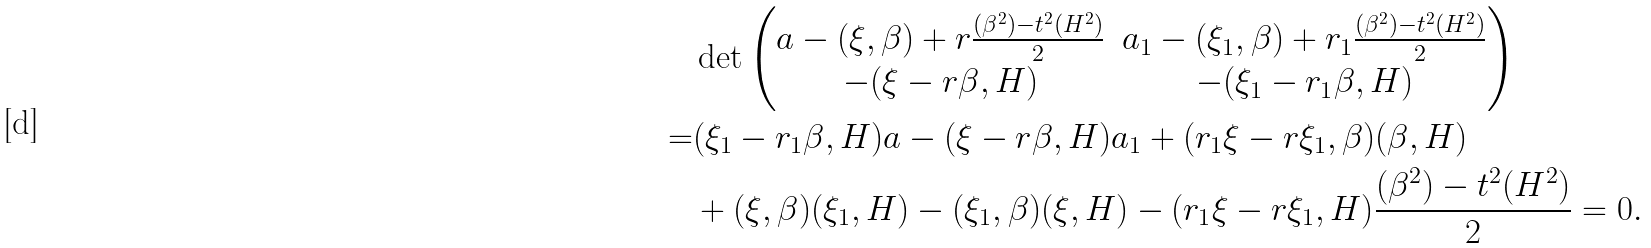<formula> <loc_0><loc_0><loc_500><loc_500>& \det \begin{pmatrix} a - ( \xi , \beta ) + r \frac { ( \beta ^ { 2 } ) - t ^ { 2 } ( H ^ { 2 } ) } { 2 } & a _ { 1 } - ( \xi _ { 1 } , \beta ) + r _ { 1 } \frac { ( \beta ^ { 2 } ) - t ^ { 2 } ( H ^ { 2 } ) } { 2 } \\ - ( \xi - r \beta , H ) & - ( \xi _ { 1 } - r _ { 1 } \beta , H ) \end{pmatrix} \\ = & ( \xi _ { 1 } - r _ { 1 } \beta , H ) a - ( \xi - r \beta , H ) a _ { 1 } + ( r _ { 1 } \xi - r \xi _ { 1 } , \beta ) ( \beta , H ) \\ & + ( \xi , \beta ) ( \xi _ { 1 } , H ) - ( \xi _ { 1 } , \beta ) ( \xi , H ) - ( r _ { 1 } \xi - r \xi _ { 1 } , H ) \frac { ( \beta ^ { 2 } ) - t ^ { 2 } ( H ^ { 2 } ) } { 2 } = 0 .</formula> 